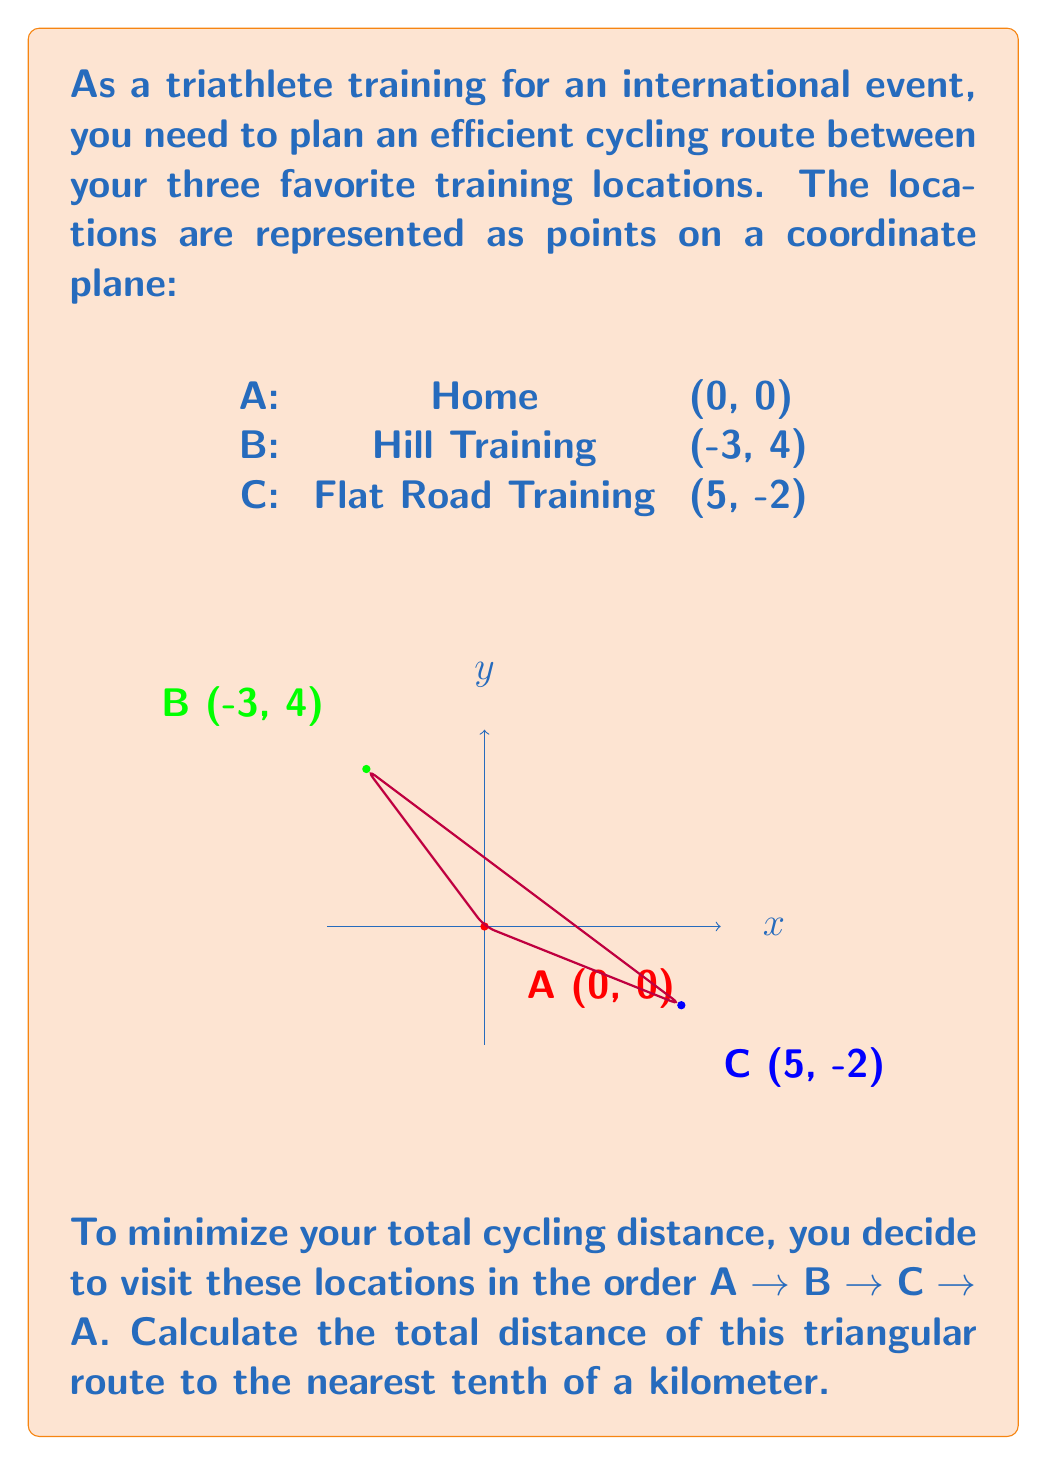Could you help me with this problem? To solve this problem, we need to calculate the distances between each pair of points and sum them up. We'll use the distance formula between two points $(x_1, y_1)$ and $(x_2, y_2)$:

$$d = \sqrt{(x_2 - x_1)^2 + (y_2 - y_1)^2}$$

1. Distance from A to B:
   $$d_{AB} = \sqrt{(-3 - 0)^2 + (4 - 0)^2} = \sqrt{9 + 16} = \sqrt{25} = 5 \text{ km}$$

2. Distance from B to C:
   $$d_{BC} = \sqrt{(5 - (-3))^2 + (-2 - 4)^2} = \sqrt{8^2 + (-6)^2} = \sqrt{64 + 36} = \sqrt{100} = 10 \text{ km}$$

3. Distance from C to A:
   $$d_{CA} = \sqrt{(0 - 5)^2 + (0 - (-2))^2} = \sqrt{(-5)^2 + 2^2} = \sqrt{25 + 4} = \sqrt{29} \approx 5.4 \text{ km}$$

4. Total distance:
   $$d_{total} = d_{AB} + d_{BC} + d_{CA} = 5 + 10 + 5.4 = 20.4 \text{ km}$$

Rounding to the nearest tenth, we get 20.4 km.
Answer: 20.4 km 